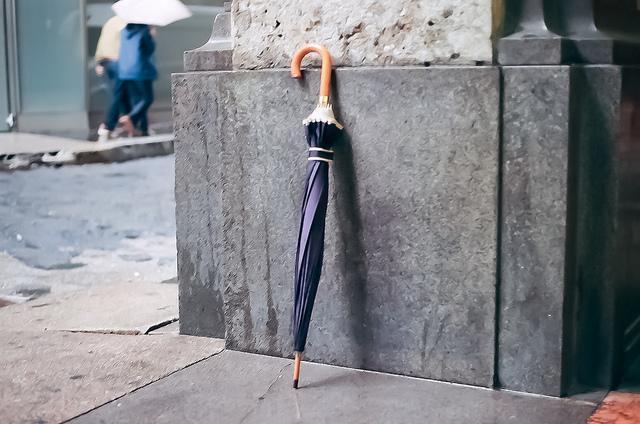How many umbrellas do you see?
Give a very brief answer. 1. How many people can be seen?
Give a very brief answer. 2. How many people have remotes in their hands?
Give a very brief answer. 0. 